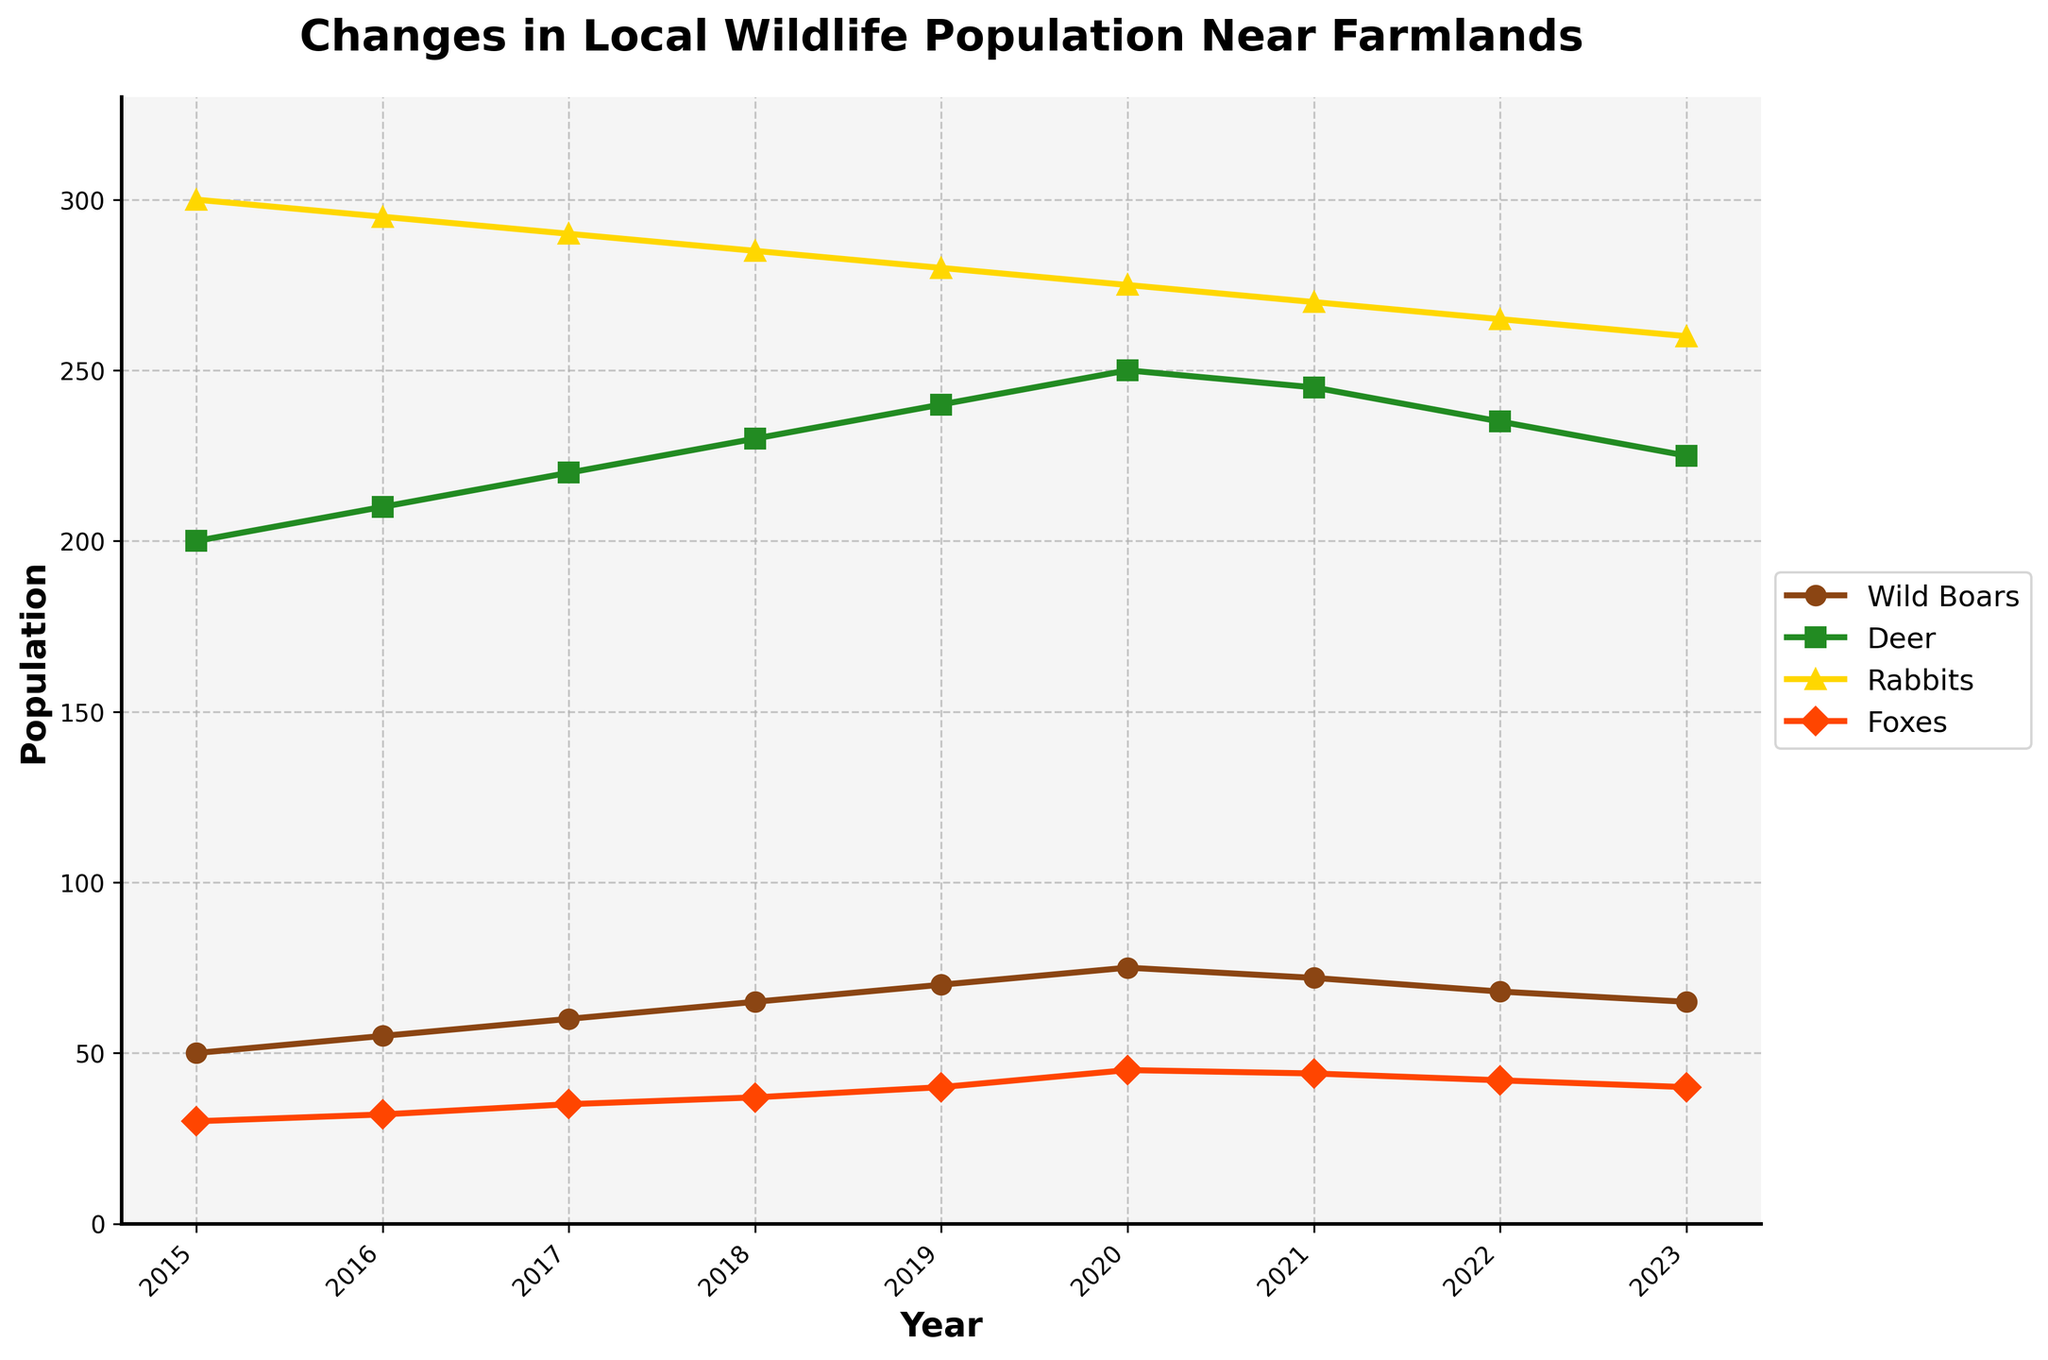what is the title of the plot? The title of the plot is clearly displayed at the top of the figure. It provides a summary of what the data represents.
Answer: Changes in Local Wildlife Population Near Farmlands Which animal had the highest population in 2023? By looking at the population values for each animal in 2023, it is clear that the deer had the highest population.
Answer: Deer How did the fox population change between 2020 and 2023? The population of foxes in 2020 was 45 and in 2023 it was 40. So, the fox population decreased by calculating 45 - 40.
Answer: Decreased by 5 What year had the highest population of wild boars? By examining the plot, the year with the highest value for wild boars appears in 2020.
Answer: 2020 What was the overall trend of the rabbit population from 2015 to 2023? By analyzing the line for rabbits, it is seen that their population steadily decreased each year from 300 in 2015 to 260 in 2023.
Answer: Decreasing Which year saw the most significant increase in the deer population? The largest increase in deer population can be observed by noting the difference between consecutive years. The difference between 2015 and 2016 is the largest (10).
Answer: 2018 How much did the total wildlife population change from 2015 to 2023? Summing up all the populations for 2015 and 2023 and then subtracting gives the change. Total for 2015 = 50+200+300+30 = 580 and for 2023 = 65+225+260+40 = 590. The change is 590 - 580 = 10.
Answer: Increased by 10 Which animals saw a population decline from 2021 to 2022? Comparing the values from 2021 to 2022 for each animal, both wild boars and deer populations declined.
Answer: Wild boars and Deer What is the average population of foxes between 2016 and 2019? To find the average, add the population of foxes for each year from 2016 to 2019 and divide by the number of years. (32+35+37+40) / 4 = 144 / 4 = 36
Answer: 36 